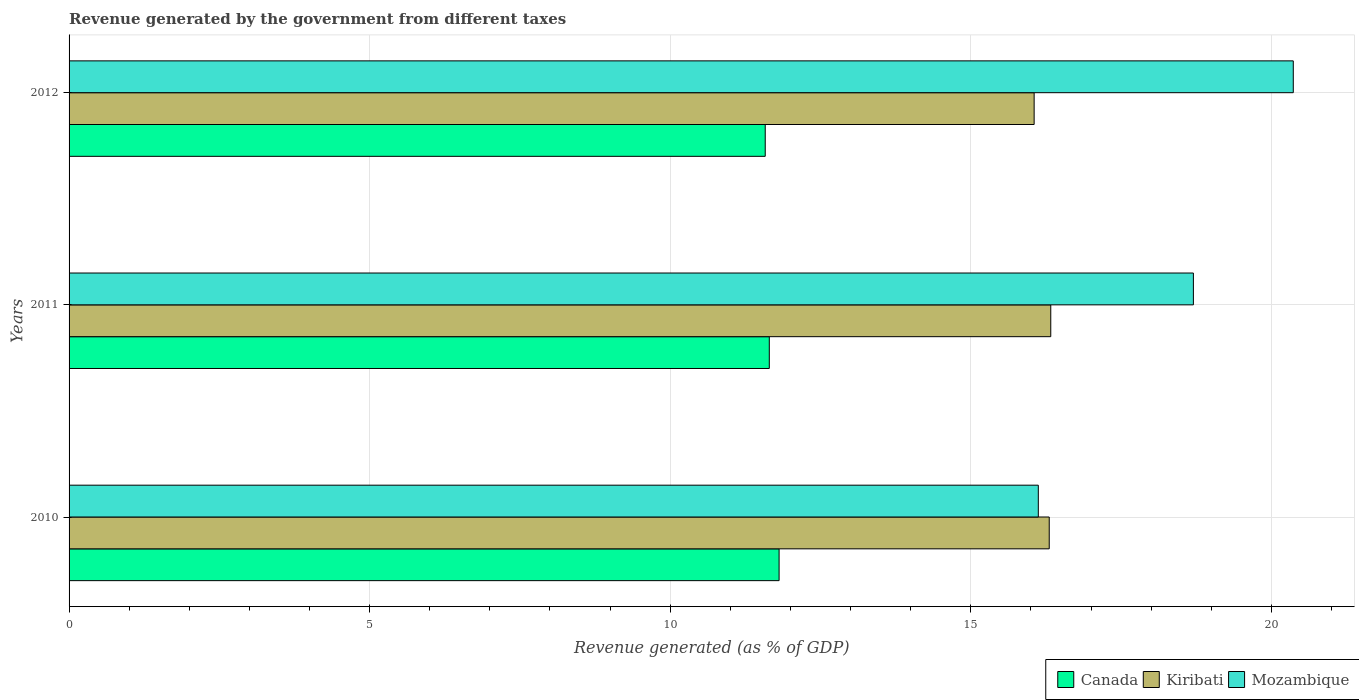How many different coloured bars are there?
Ensure brevity in your answer.  3. How many groups of bars are there?
Provide a short and direct response. 3. Are the number of bars on each tick of the Y-axis equal?
Offer a terse response. Yes. How many bars are there on the 2nd tick from the top?
Your response must be concise. 3. In how many cases, is the number of bars for a given year not equal to the number of legend labels?
Ensure brevity in your answer.  0. What is the revenue generated by the government in Kiribati in 2011?
Keep it short and to the point. 16.33. Across all years, what is the maximum revenue generated by the government in Mozambique?
Provide a succinct answer. 20.37. Across all years, what is the minimum revenue generated by the government in Mozambique?
Offer a terse response. 16.12. In which year was the revenue generated by the government in Mozambique minimum?
Make the answer very short. 2010. What is the total revenue generated by the government in Canada in the graph?
Give a very brief answer. 35.04. What is the difference between the revenue generated by the government in Canada in 2010 and that in 2012?
Offer a very short reply. 0.23. What is the difference between the revenue generated by the government in Canada in 2010 and the revenue generated by the government in Mozambique in 2012?
Your answer should be compact. -8.55. What is the average revenue generated by the government in Canada per year?
Provide a short and direct response. 11.68. In the year 2011, what is the difference between the revenue generated by the government in Mozambique and revenue generated by the government in Canada?
Provide a succinct answer. 7.05. What is the ratio of the revenue generated by the government in Canada in 2010 to that in 2012?
Offer a very short reply. 1.02. Is the difference between the revenue generated by the government in Mozambique in 2010 and 2012 greater than the difference between the revenue generated by the government in Canada in 2010 and 2012?
Ensure brevity in your answer.  No. What is the difference between the highest and the second highest revenue generated by the government in Kiribati?
Your answer should be very brief. 0.03. What is the difference between the highest and the lowest revenue generated by the government in Canada?
Your answer should be very brief. 0.23. In how many years, is the revenue generated by the government in Kiribati greater than the average revenue generated by the government in Kiribati taken over all years?
Keep it short and to the point. 2. What does the 3rd bar from the top in 2011 represents?
Offer a terse response. Canada. What does the 3rd bar from the bottom in 2010 represents?
Ensure brevity in your answer.  Mozambique. Is it the case that in every year, the sum of the revenue generated by the government in Kiribati and revenue generated by the government in Mozambique is greater than the revenue generated by the government in Canada?
Provide a succinct answer. Yes. How many years are there in the graph?
Provide a short and direct response. 3. Are the values on the major ticks of X-axis written in scientific E-notation?
Your answer should be very brief. No. Does the graph contain any zero values?
Provide a succinct answer. No. Where does the legend appear in the graph?
Offer a terse response. Bottom right. How are the legend labels stacked?
Your response must be concise. Horizontal. What is the title of the graph?
Keep it short and to the point. Revenue generated by the government from different taxes. What is the label or title of the X-axis?
Offer a terse response. Revenue generated (as % of GDP). What is the Revenue generated (as % of GDP) in Canada in 2010?
Your response must be concise. 11.81. What is the Revenue generated (as % of GDP) in Kiribati in 2010?
Provide a succinct answer. 16.31. What is the Revenue generated (as % of GDP) of Mozambique in 2010?
Your answer should be very brief. 16.12. What is the Revenue generated (as % of GDP) of Canada in 2011?
Give a very brief answer. 11.65. What is the Revenue generated (as % of GDP) in Kiribati in 2011?
Ensure brevity in your answer.  16.33. What is the Revenue generated (as % of GDP) of Mozambique in 2011?
Offer a terse response. 18.7. What is the Revenue generated (as % of GDP) in Canada in 2012?
Offer a terse response. 11.58. What is the Revenue generated (as % of GDP) of Kiribati in 2012?
Provide a short and direct response. 16.05. What is the Revenue generated (as % of GDP) in Mozambique in 2012?
Your answer should be very brief. 20.37. Across all years, what is the maximum Revenue generated (as % of GDP) of Canada?
Make the answer very short. 11.81. Across all years, what is the maximum Revenue generated (as % of GDP) of Kiribati?
Offer a very short reply. 16.33. Across all years, what is the maximum Revenue generated (as % of GDP) of Mozambique?
Your response must be concise. 20.37. Across all years, what is the minimum Revenue generated (as % of GDP) of Canada?
Provide a short and direct response. 11.58. Across all years, what is the minimum Revenue generated (as % of GDP) of Kiribati?
Give a very brief answer. 16.05. Across all years, what is the minimum Revenue generated (as % of GDP) of Mozambique?
Make the answer very short. 16.12. What is the total Revenue generated (as % of GDP) in Canada in the graph?
Give a very brief answer. 35.04. What is the total Revenue generated (as % of GDP) in Kiribati in the graph?
Provide a succinct answer. 48.69. What is the total Revenue generated (as % of GDP) of Mozambique in the graph?
Offer a very short reply. 55.19. What is the difference between the Revenue generated (as % of GDP) in Canada in 2010 and that in 2011?
Provide a succinct answer. 0.16. What is the difference between the Revenue generated (as % of GDP) in Kiribati in 2010 and that in 2011?
Provide a succinct answer. -0.03. What is the difference between the Revenue generated (as % of GDP) in Mozambique in 2010 and that in 2011?
Give a very brief answer. -2.58. What is the difference between the Revenue generated (as % of GDP) of Canada in 2010 and that in 2012?
Keep it short and to the point. 0.23. What is the difference between the Revenue generated (as % of GDP) of Kiribati in 2010 and that in 2012?
Keep it short and to the point. 0.25. What is the difference between the Revenue generated (as % of GDP) in Mozambique in 2010 and that in 2012?
Your answer should be very brief. -4.24. What is the difference between the Revenue generated (as % of GDP) of Canada in 2011 and that in 2012?
Provide a short and direct response. 0.07. What is the difference between the Revenue generated (as % of GDP) in Kiribati in 2011 and that in 2012?
Give a very brief answer. 0.28. What is the difference between the Revenue generated (as % of GDP) of Mozambique in 2011 and that in 2012?
Provide a short and direct response. -1.66. What is the difference between the Revenue generated (as % of GDP) in Canada in 2010 and the Revenue generated (as % of GDP) in Kiribati in 2011?
Offer a terse response. -4.52. What is the difference between the Revenue generated (as % of GDP) in Canada in 2010 and the Revenue generated (as % of GDP) in Mozambique in 2011?
Offer a very short reply. -6.89. What is the difference between the Revenue generated (as % of GDP) of Kiribati in 2010 and the Revenue generated (as % of GDP) of Mozambique in 2011?
Offer a very short reply. -2.4. What is the difference between the Revenue generated (as % of GDP) in Canada in 2010 and the Revenue generated (as % of GDP) in Kiribati in 2012?
Offer a terse response. -4.24. What is the difference between the Revenue generated (as % of GDP) of Canada in 2010 and the Revenue generated (as % of GDP) of Mozambique in 2012?
Ensure brevity in your answer.  -8.55. What is the difference between the Revenue generated (as % of GDP) in Kiribati in 2010 and the Revenue generated (as % of GDP) in Mozambique in 2012?
Give a very brief answer. -4.06. What is the difference between the Revenue generated (as % of GDP) in Canada in 2011 and the Revenue generated (as % of GDP) in Kiribati in 2012?
Make the answer very short. -4.41. What is the difference between the Revenue generated (as % of GDP) of Canada in 2011 and the Revenue generated (as % of GDP) of Mozambique in 2012?
Your answer should be compact. -8.72. What is the difference between the Revenue generated (as % of GDP) in Kiribati in 2011 and the Revenue generated (as % of GDP) in Mozambique in 2012?
Offer a very short reply. -4.03. What is the average Revenue generated (as % of GDP) of Canada per year?
Ensure brevity in your answer.  11.68. What is the average Revenue generated (as % of GDP) in Kiribati per year?
Give a very brief answer. 16.23. What is the average Revenue generated (as % of GDP) of Mozambique per year?
Your answer should be very brief. 18.4. In the year 2010, what is the difference between the Revenue generated (as % of GDP) of Canada and Revenue generated (as % of GDP) of Kiribati?
Provide a short and direct response. -4.49. In the year 2010, what is the difference between the Revenue generated (as % of GDP) in Canada and Revenue generated (as % of GDP) in Mozambique?
Make the answer very short. -4.31. In the year 2010, what is the difference between the Revenue generated (as % of GDP) of Kiribati and Revenue generated (as % of GDP) of Mozambique?
Your answer should be very brief. 0.18. In the year 2011, what is the difference between the Revenue generated (as % of GDP) of Canada and Revenue generated (as % of GDP) of Kiribati?
Offer a very short reply. -4.68. In the year 2011, what is the difference between the Revenue generated (as % of GDP) in Canada and Revenue generated (as % of GDP) in Mozambique?
Your answer should be very brief. -7.05. In the year 2011, what is the difference between the Revenue generated (as % of GDP) in Kiribati and Revenue generated (as % of GDP) in Mozambique?
Your answer should be compact. -2.37. In the year 2012, what is the difference between the Revenue generated (as % of GDP) in Canada and Revenue generated (as % of GDP) in Kiribati?
Ensure brevity in your answer.  -4.47. In the year 2012, what is the difference between the Revenue generated (as % of GDP) in Canada and Revenue generated (as % of GDP) in Mozambique?
Ensure brevity in your answer.  -8.78. In the year 2012, what is the difference between the Revenue generated (as % of GDP) of Kiribati and Revenue generated (as % of GDP) of Mozambique?
Offer a terse response. -4.31. What is the ratio of the Revenue generated (as % of GDP) in Mozambique in 2010 to that in 2011?
Make the answer very short. 0.86. What is the ratio of the Revenue generated (as % of GDP) in Canada in 2010 to that in 2012?
Keep it short and to the point. 1.02. What is the ratio of the Revenue generated (as % of GDP) in Kiribati in 2010 to that in 2012?
Make the answer very short. 1.02. What is the ratio of the Revenue generated (as % of GDP) of Mozambique in 2010 to that in 2012?
Your answer should be compact. 0.79. What is the ratio of the Revenue generated (as % of GDP) in Canada in 2011 to that in 2012?
Keep it short and to the point. 1.01. What is the ratio of the Revenue generated (as % of GDP) of Kiribati in 2011 to that in 2012?
Your response must be concise. 1.02. What is the ratio of the Revenue generated (as % of GDP) of Mozambique in 2011 to that in 2012?
Provide a short and direct response. 0.92. What is the difference between the highest and the second highest Revenue generated (as % of GDP) in Canada?
Offer a very short reply. 0.16. What is the difference between the highest and the second highest Revenue generated (as % of GDP) of Kiribati?
Offer a terse response. 0.03. What is the difference between the highest and the second highest Revenue generated (as % of GDP) of Mozambique?
Your answer should be very brief. 1.66. What is the difference between the highest and the lowest Revenue generated (as % of GDP) of Canada?
Keep it short and to the point. 0.23. What is the difference between the highest and the lowest Revenue generated (as % of GDP) of Kiribati?
Offer a very short reply. 0.28. What is the difference between the highest and the lowest Revenue generated (as % of GDP) of Mozambique?
Keep it short and to the point. 4.24. 